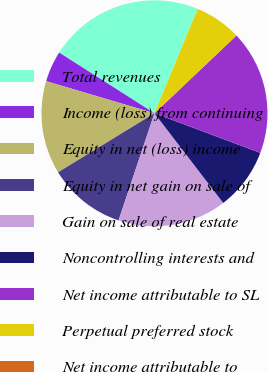Convert chart. <chart><loc_0><loc_0><loc_500><loc_500><pie_chart><fcel>Total revenues<fcel>Income (loss) from continuing<fcel>Equity in net (loss) income<fcel>Equity in net gain on sale of<fcel>Gain on sale of real estate<fcel>Noncontrolling interests and<fcel>Net income attributable to SL<fcel>Perpetual preferred stock<fcel>Net income attributable to<nl><fcel>22.22%<fcel>4.44%<fcel>13.33%<fcel>11.11%<fcel>15.56%<fcel>8.89%<fcel>17.78%<fcel>6.67%<fcel>0.0%<nl></chart> 